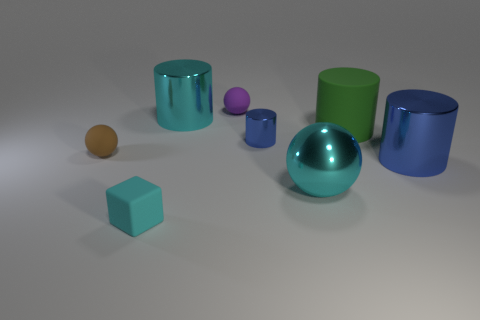What time of day does the lighting suggest in the image? The lighting in the image appears soft and diffuse, without strong shadows or highlights that would suggest a specific time of day. It's more reminiscent of studio lighting designed to evenly illuminate the scene, rather than natural lighting which varies throughout the day. 